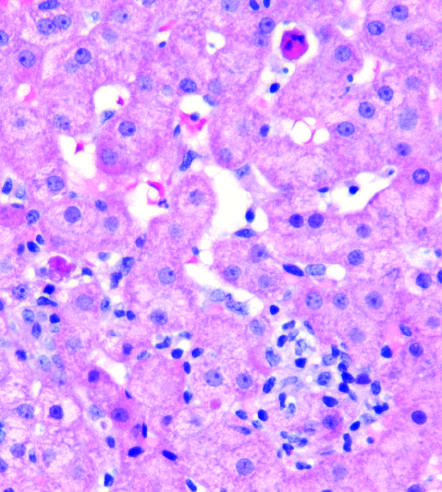does this biopsy from a patient with lobular hepatitis due to chronic hepatitis c show scattered apoptotic hepatocytes and a patchy inflammatory infiltrate?
Answer the question using a single word or phrase. Yes 